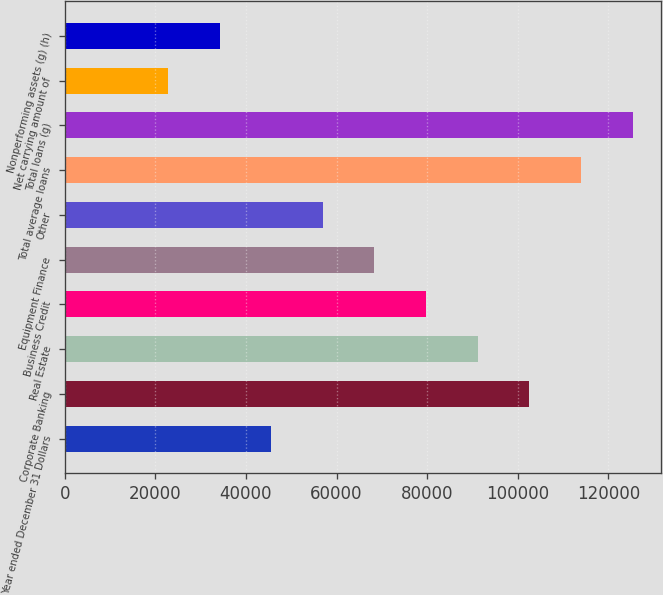Convert chart to OTSL. <chart><loc_0><loc_0><loc_500><loc_500><bar_chart><fcel>Year ended December 31 Dollars<fcel>Corporate Banking<fcel>Real Estate<fcel>Business Credit<fcel>Equipment Finance<fcel>Other<fcel>Total average loans<fcel>Total loans (g)<fcel>Net carrying amount of<fcel>Nonperforming assets (g) (h)<nl><fcel>45578.8<fcel>102542<fcel>91149.6<fcel>79756.9<fcel>68364.2<fcel>56971.5<fcel>113935<fcel>125328<fcel>22793.4<fcel>34186.1<nl></chart> 